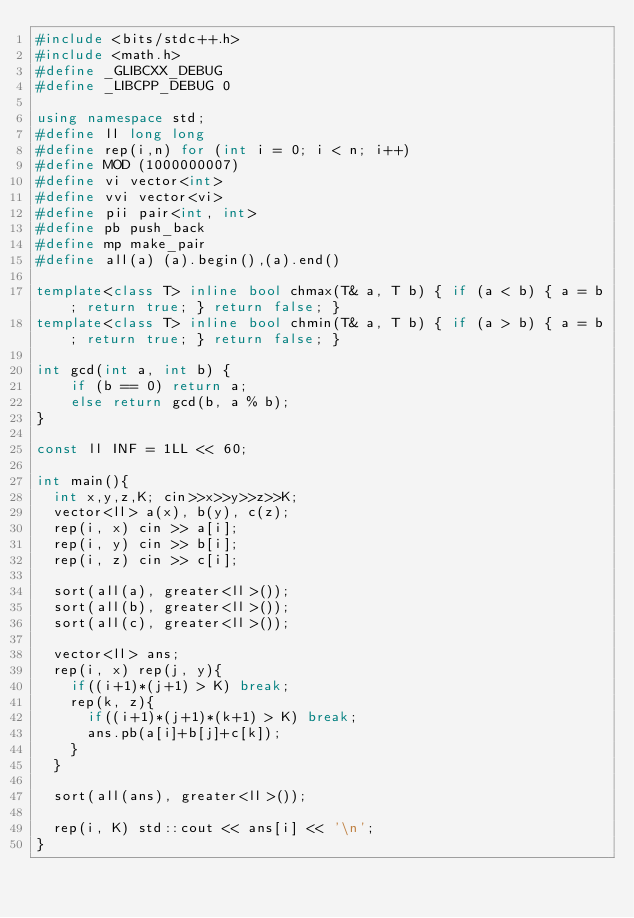Convert code to text. <code><loc_0><loc_0><loc_500><loc_500><_C++_>#include <bits/stdc++.h>
#include <math.h>
#define _GLIBCXX_DEBUG
#define _LIBCPP_DEBUG 0

using namespace std;
#define ll long long
#define rep(i,n) for (int i = 0; i < n; i++)
#define MOD (1000000007)
#define vi vector<int>
#define vvi vector<vi>
#define pii pair<int, int>
#define pb push_back
#define mp make_pair
#define all(a) (a).begin(),(a).end()

template<class T> inline bool chmax(T& a, T b) { if (a < b) { a = b; return true; } return false; }
template<class T> inline bool chmin(T& a, T b) { if (a > b) { a = b; return true; } return false; }

int gcd(int a, int b) {
    if (b == 0) return a;
    else return gcd(b, a % b);
}

const ll INF = 1LL << 60;

int main(){
  int x,y,z,K; cin>>x>>y>>z>>K;
  vector<ll> a(x), b(y), c(z);
  rep(i, x) cin >> a[i];
  rep(i, y) cin >> b[i];
  rep(i, z) cin >> c[i];

  sort(all(a), greater<ll>());
  sort(all(b), greater<ll>());
  sort(all(c), greater<ll>());

  vector<ll> ans;
  rep(i, x) rep(j, y){
    if((i+1)*(j+1) > K) break;
    rep(k, z){
      if((i+1)*(j+1)*(k+1) > K) break;
      ans.pb(a[i]+b[j]+c[k]);
    }
  }

  sort(all(ans), greater<ll>());

  rep(i, K) std::cout << ans[i] << '\n';
}
</code> 